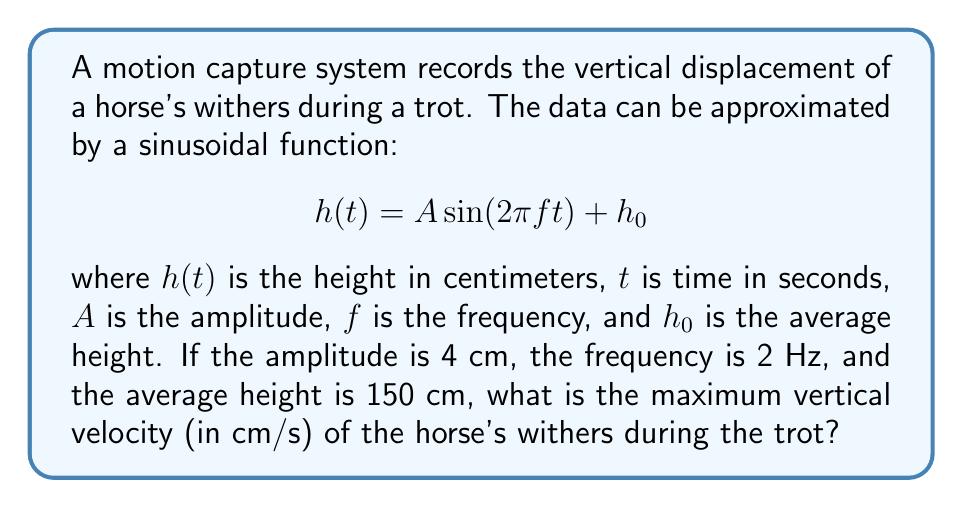Give your solution to this math problem. To solve this problem, we'll follow these steps:

1) The given function for the vertical displacement is:
   $$h(t) = 4 \sin(2\pi \cdot 2t) + 150$$

2) To find the velocity, we need to differentiate $h(t)$ with respect to time:
   $$v(t) = \frac{dh}{dt} = 4 \cdot 2\pi \cdot 2 \cos(2\pi \cdot 2t)$$
   $$v(t) = 16\pi \cos(4\pi t)$$

3) The maximum velocity occurs when $\cos(4\pi t) = \pm 1$, which happens when $4\pi t = 0, \pi, 2\pi, ...$

4) At these points, the absolute value of the velocity is:
   $$|v_{max}| = 16\pi$$

5) Convert this to cm/s:
   $$v_{max} = 16\pi \approx 50.27 \text{ cm/s}$$

Therefore, the maximum vertical velocity of the horse's withers during the trot is approximately 50.27 cm/s.
Answer: 50.27 cm/s 